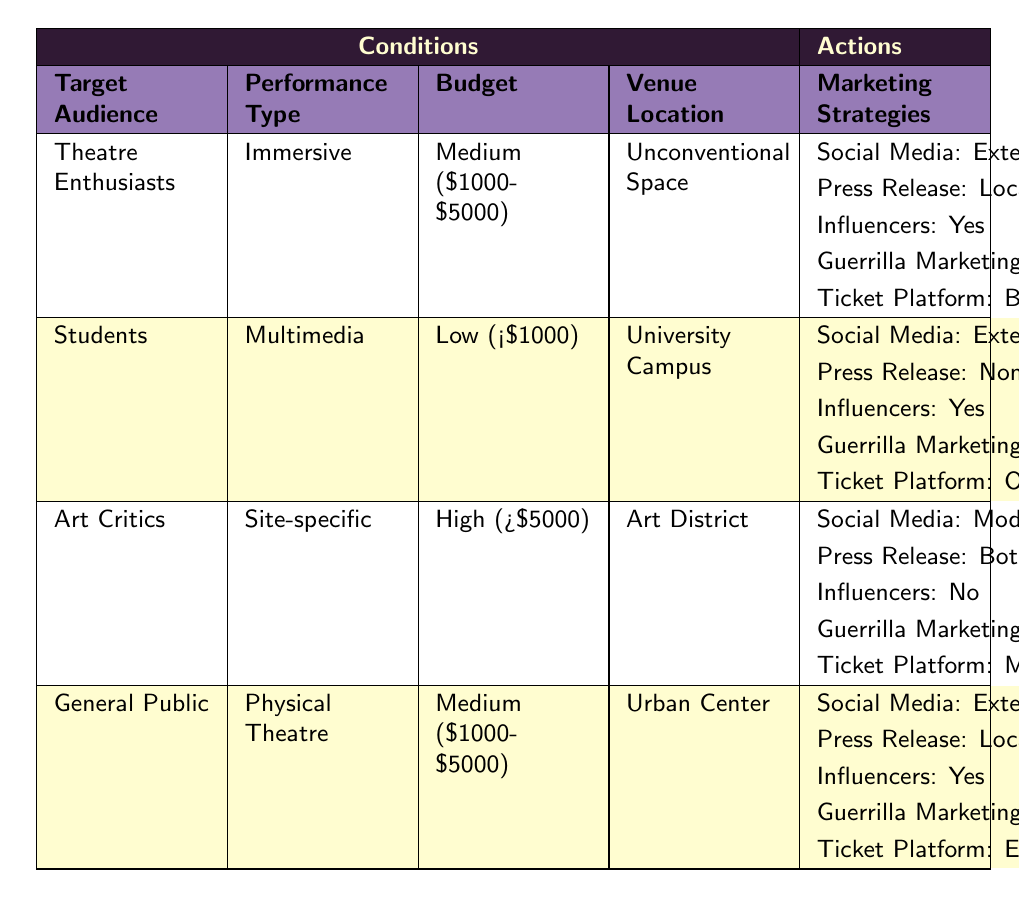What is the marketing strategy for "Theatre Enthusiasts"? The row corresponding to the target audience "Theatre Enthusiasts" lists the actions taken, which include an extensive social media campaign, a local press release, collaboration with influencers (yes), moderate guerrilla marketing, and using Brown Paper Tickets for online ticketing.
Answer: Extensive social media campaign, local press release, collaboration with influencers (yes), moderate guerrilla marketing, Brown Paper Tickets What budget is associated with the "Students" performance type? In the row for "Students," the budget is clearly stated as Low ($1000).
Answer: Low (<$1000) Is there a collaboration with influencers for "Art Critics"? Looking at the "Art Critics" row, it states no collaboration with influencers. Thus, the answer is false.
Answer: No Which performance type is paired with an extensive guerrilla marketing strategy for the "General Public"? The general public performance type is "Physical Theatre," which has extensive guerrilla marketing as described in its associated actions.
Answer: Physical Theatre What are the differences between the social media strategies for "Art Critics" and "General Public"? "Art Critics" has a moderate social media campaign while "General Public" has an extensive one. The difference in social media strategy is moderate versus extensive, which shows a clear deviation in approach based on the target audience.
Answer: Moderate vs. Extensive How many marketing strategies are mentioned for "Students"? The "Students" row contains five specific marketing strategies: extensive social media campaign, no press release, collaboration with influencers (yes), extensive guerrilla marketing, and using the own website for ticketing. Therefore, the total number is five.
Answer: Five What ticket platforms are suggested for "Theatre Enthusiasts" and "Art Critics"? The actions for "Theatre Enthusiasts" suggest using Brown Paper Tickets while "Art Critics" recommend Multiple Platforms.
Answer: Brown Paper Tickets and Multiple Platforms Does "General Public" require a national press release? In the row for the "General Public," the press release strategy is classified as local, indicating that no national press release is needed.
Answer: No What is the combined budget for "Art Critics" and "Students"? "Art Critics" have a high budget (greater than $5000), and "Students" have a low budget (less than $1000). The combined aspect does not yield a numerical addition since they are categorical but reflects a range from low to high. The point here is the difference in budget levels (low vs. high).
Answer: Low (<$1000) and High (>$5000) 